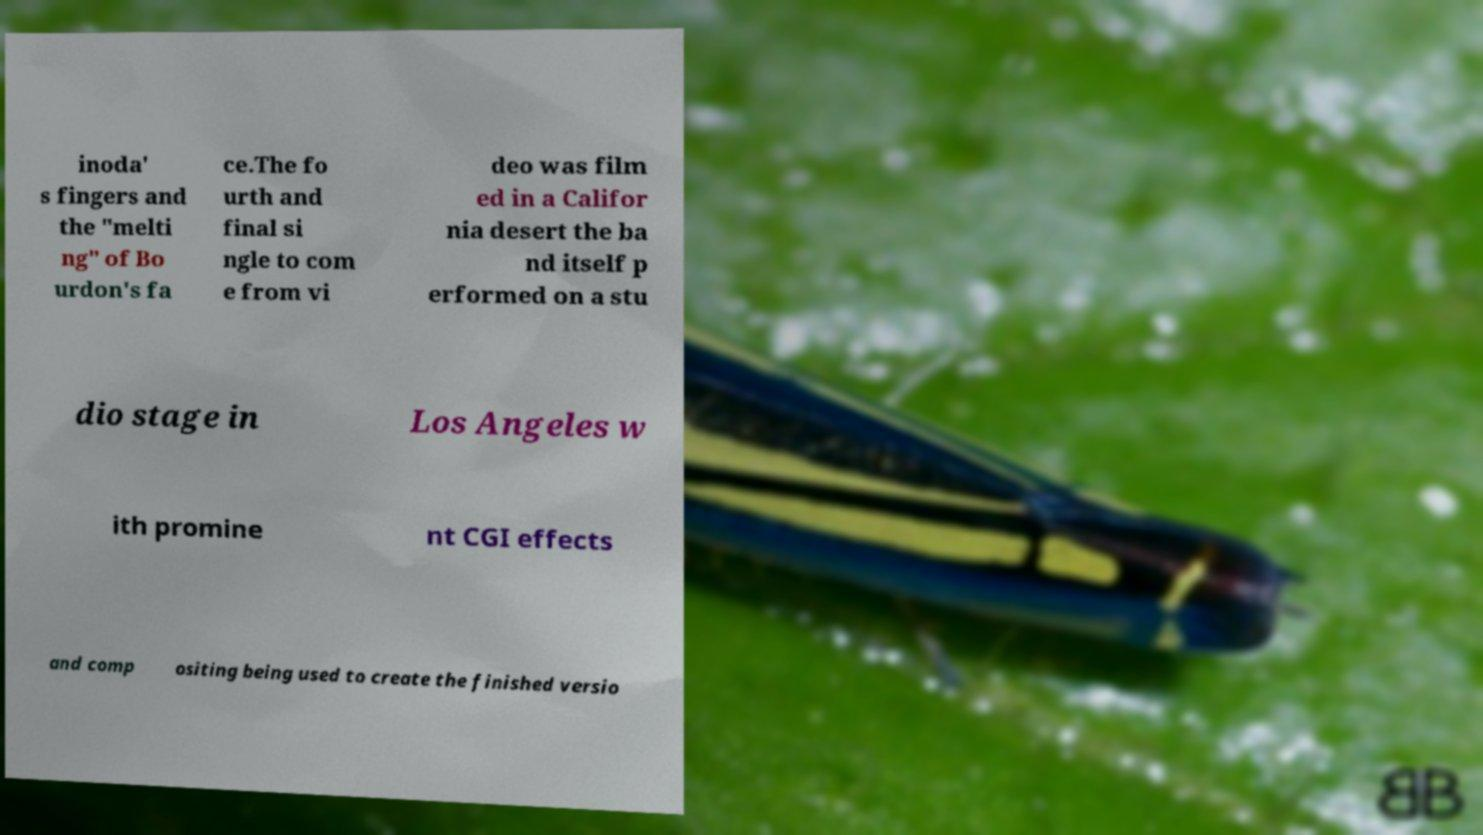I need the written content from this picture converted into text. Can you do that? inoda' s fingers and the "melti ng" of Bo urdon's fa ce.The fo urth and final si ngle to com e from vi deo was film ed in a Califor nia desert the ba nd itself p erformed on a stu dio stage in Los Angeles w ith promine nt CGI effects and comp ositing being used to create the finished versio 